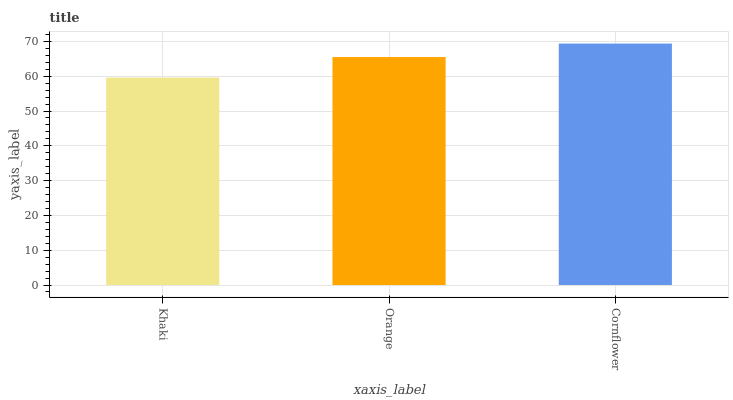Is Khaki the minimum?
Answer yes or no. Yes. Is Cornflower the maximum?
Answer yes or no. Yes. Is Orange the minimum?
Answer yes or no. No. Is Orange the maximum?
Answer yes or no. No. Is Orange greater than Khaki?
Answer yes or no. Yes. Is Khaki less than Orange?
Answer yes or no. Yes. Is Khaki greater than Orange?
Answer yes or no. No. Is Orange less than Khaki?
Answer yes or no. No. Is Orange the high median?
Answer yes or no. Yes. Is Orange the low median?
Answer yes or no. Yes. Is Khaki the high median?
Answer yes or no. No. Is Cornflower the low median?
Answer yes or no. No. 